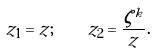<formula> <loc_0><loc_0><loc_500><loc_500>z _ { 1 } = z ; \quad z _ { 2 } = \frac { \zeta ^ { k } } { z } .</formula> 